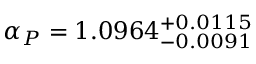Convert formula to latex. <formula><loc_0><loc_0><loc_500><loc_500>\alpha _ { P } = 1 . 0 9 6 4 _ { - 0 . 0 0 9 1 } ^ { + 0 . 0 1 1 5 }</formula> 